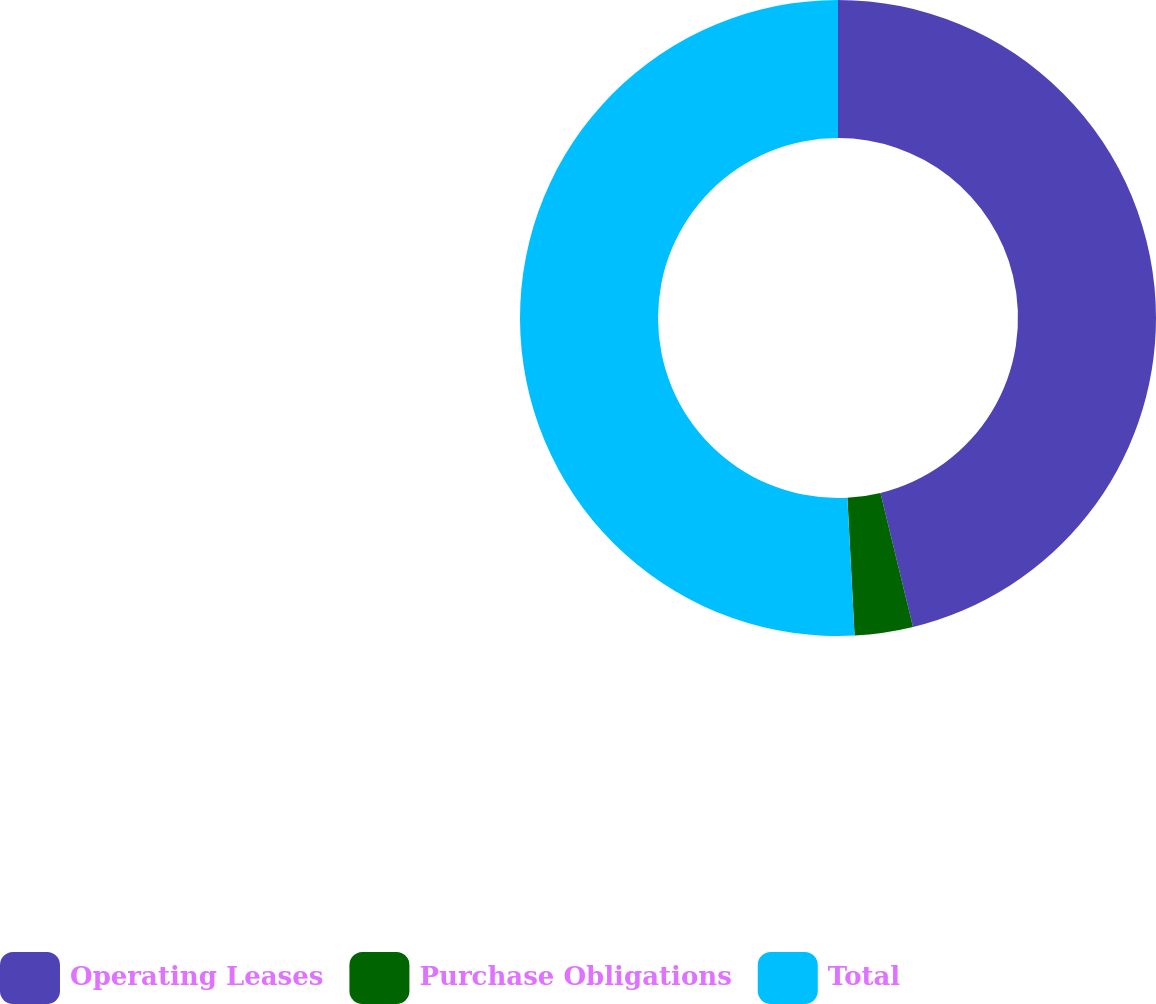Convert chart to OTSL. <chart><loc_0><loc_0><loc_500><loc_500><pie_chart><fcel>Operating Leases<fcel>Purchase Obligations<fcel>Total<nl><fcel>46.21%<fcel>2.96%<fcel>50.83%<nl></chart> 